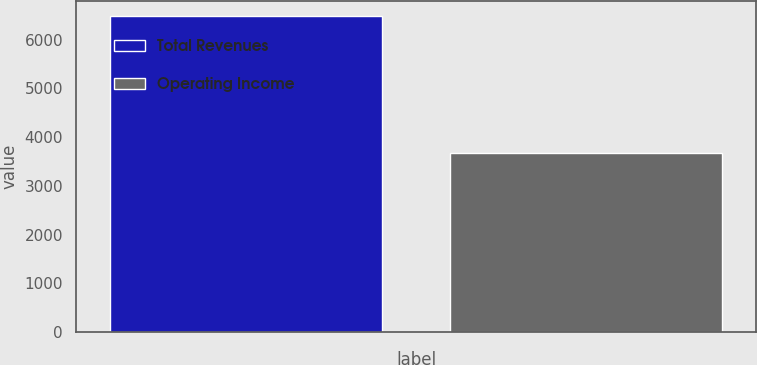Convert chart to OTSL. <chart><loc_0><loc_0><loc_500><loc_500><bar_chart><fcel>Total Revenues<fcel>Operating Income<nl><fcel>6474<fcel>3675<nl></chart> 